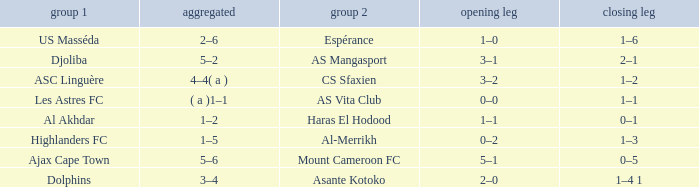What is the 2nd leg of team 1 Dolphins? 1–4 1. 